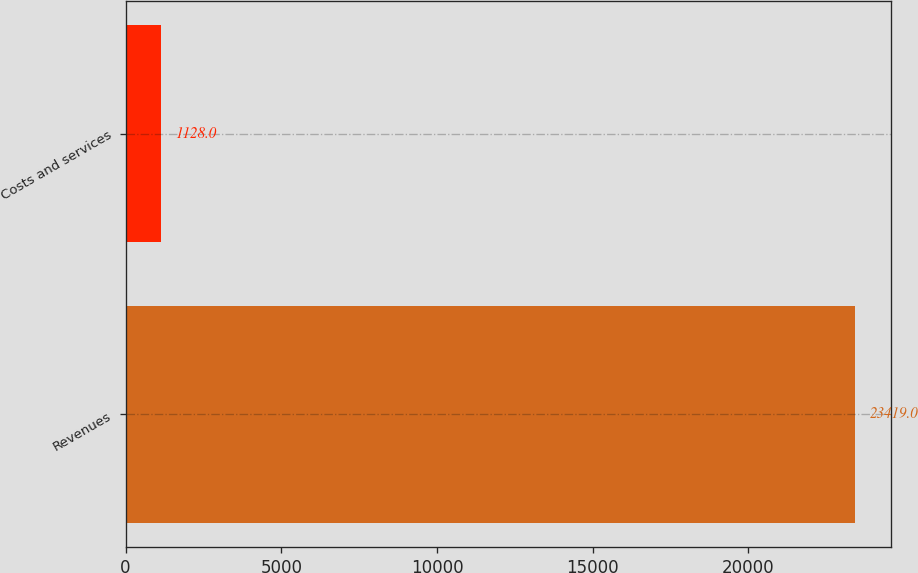Convert chart to OTSL. <chart><loc_0><loc_0><loc_500><loc_500><bar_chart><fcel>Revenues<fcel>Costs and services<nl><fcel>23419<fcel>1128<nl></chart> 